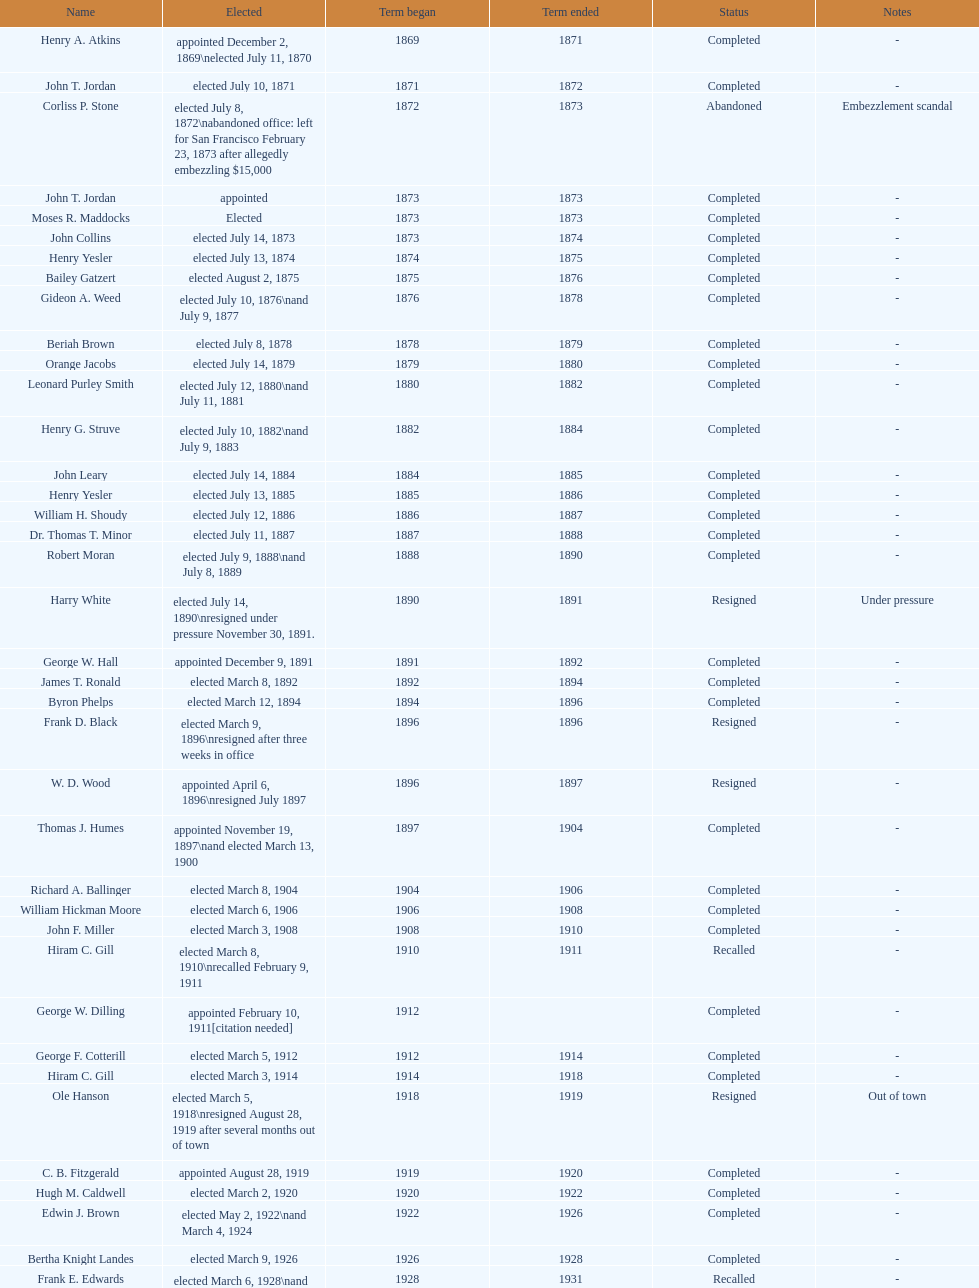Who was the first mayor in the 1900's? Richard A. Ballinger. 